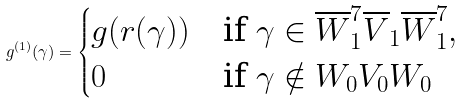Convert formula to latex. <formula><loc_0><loc_0><loc_500><loc_500>g ^ { ( 1 ) } ( \gamma ) = \begin{cases} g ( r ( \gamma ) ) & \text {if } \gamma \in \overline { W } ^ { 7 } _ { 1 } \overline { V } _ { 1 } \overline { W } ^ { 7 } _ { 1 } , \\ 0 & \text {if } \gamma \notin W _ { 0 } V _ { 0 } W _ { 0 } \end{cases}</formula> 